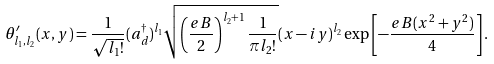<formula> <loc_0><loc_0><loc_500><loc_500>\theta ^ { \prime } _ { l _ { 1 } , l _ { 2 } } ( x , y ) = \frac { 1 } { \sqrt { l _ { 1 } ! } } ( a _ { d } ^ { \dag } ) ^ { l _ { 1 } } \sqrt { \left ( \frac { e B } { 2 } \right ) ^ { l _ { 2 } + 1 } \frac { 1 } { \pi l _ { 2 } ! } } ( x - i y ) ^ { l _ { 2 } } \exp \left [ - \frac { e B ( x ^ { 2 } + y ^ { 2 } ) } { 4 } \right ] .</formula> 